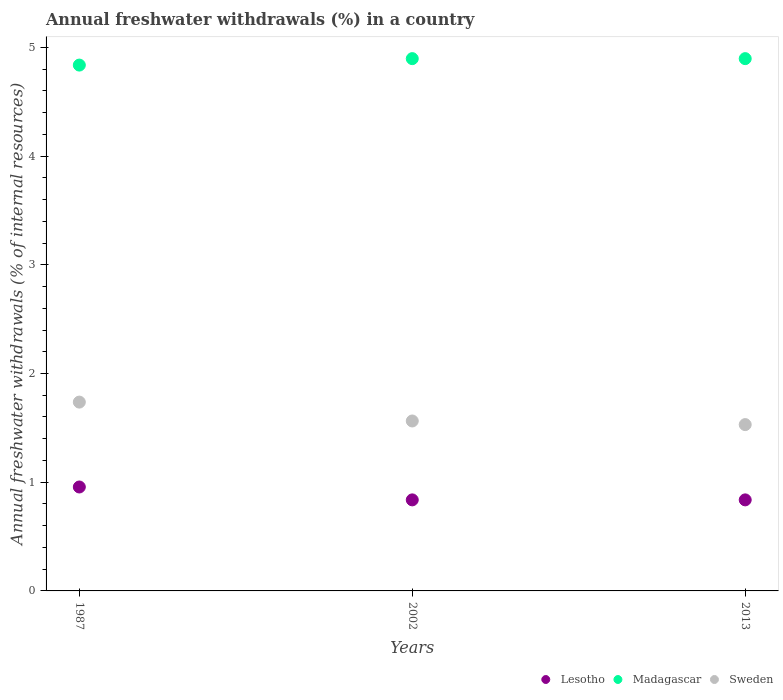How many different coloured dotlines are there?
Provide a short and direct response. 3. Is the number of dotlines equal to the number of legend labels?
Offer a very short reply. Yes. What is the percentage of annual freshwater withdrawals in Lesotho in 1987?
Provide a succinct answer. 0.96. Across all years, what is the maximum percentage of annual freshwater withdrawals in Lesotho?
Offer a terse response. 0.96. Across all years, what is the minimum percentage of annual freshwater withdrawals in Sweden?
Give a very brief answer. 1.53. What is the total percentage of annual freshwater withdrawals in Madagascar in the graph?
Offer a terse response. 14.63. What is the difference between the percentage of annual freshwater withdrawals in Sweden in 2002 and that in 2013?
Provide a short and direct response. 0.03. What is the difference between the percentage of annual freshwater withdrawals in Sweden in 2013 and the percentage of annual freshwater withdrawals in Lesotho in 1987?
Your response must be concise. 0.57. What is the average percentage of annual freshwater withdrawals in Madagascar per year?
Offer a very short reply. 4.88. In the year 2013, what is the difference between the percentage of annual freshwater withdrawals in Lesotho and percentage of annual freshwater withdrawals in Madagascar?
Your response must be concise. -4.06. What is the ratio of the percentage of annual freshwater withdrawals in Madagascar in 1987 to that in 2013?
Keep it short and to the point. 0.99. What is the difference between the highest and the lowest percentage of annual freshwater withdrawals in Madagascar?
Provide a succinct answer. 0.06. Is it the case that in every year, the sum of the percentage of annual freshwater withdrawals in Madagascar and percentage of annual freshwater withdrawals in Sweden  is greater than the percentage of annual freshwater withdrawals in Lesotho?
Make the answer very short. Yes. Is the percentage of annual freshwater withdrawals in Madagascar strictly less than the percentage of annual freshwater withdrawals in Lesotho over the years?
Your answer should be very brief. No. How many dotlines are there?
Your answer should be compact. 3. How many years are there in the graph?
Give a very brief answer. 3. Are the values on the major ticks of Y-axis written in scientific E-notation?
Offer a terse response. No. Does the graph contain grids?
Offer a very short reply. No. Where does the legend appear in the graph?
Your answer should be compact. Bottom right. How many legend labels are there?
Provide a succinct answer. 3. What is the title of the graph?
Offer a very short reply. Annual freshwater withdrawals (%) in a country. Does "Spain" appear as one of the legend labels in the graph?
Provide a short and direct response. No. What is the label or title of the Y-axis?
Provide a succinct answer. Annual freshwater withdrawals (% of internal resources). What is the Annual freshwater withdrawals (% of internal resources) in Lesotho in 1987?
Your answer should be very brief. 0.96. What is the Annual freshwater withdrawals (% of internal resources) in Madagascar in 1987?
Keep it short and to the point. 4.84. What is the Annual freshwater withdrawals (% of internal resources) in Sweden in 1987?
Provide a succinct answer. 1.74. What is the Annual freshwater withdrawals (% of internal resources) of Lesotho in 2002?
Offer a terse response. 0.84. What is the Annual freshwater withdrawals (% of internal resources) in Madagascar in 2002?
Provide a succinct answer. 4.9. What is the Annual freshwater withdrawals (% of internal resources) in Sweden in 2002?
Keep it short and to the point. 1.56. What is the Annual freshwater withdrawals (% of internal resources) in Lesotho in 2013?
Provide a succinct answer. 0.84. What is the Annual freshwater withdrawals (% of internal resources) in Madagascar in 2013?
Your answer should be very brief. 4.9. What is the Annual freshwater withdrawals (% of internal resources) in Sweden in 2013?
Give a very brief answer. 1.53. Across all years, what is the maximum Annual freshwater withdrawals (% of internal resources) of Lesotho?
Your answer should be very brief. 0.96. Across all years, what is the maximum Annual freshwater withdrawals (% of internal resources) of Madagascar?
Your answer should be compact. 4.9. Across all years, what is the maximum Annual freshwater withdrawals (% of internal resources) in Sweden?
Provide a short and direct response. 1.74. Across all years, what is the minimum Annual freshwater withdrawals (% of internal resources) of Lesotho?
Provide a short and direct response. 0.84. Across all years, what is the minimum Annual freshwater withdrawals (% of internal resources) of Madagascar?
Ensure brevity in your answer.  4.84. Across all years, what is the minimum Annual freshwater withdrawals (% of internal resources) of Sweden?
Your answer should be compact. 1.53. What is the total Annual freshwater withdrawals (% of internal resources) in Lesotho in the graph?
Your response must be concise. 2.63. What is the total Annual freshwater withdrawals (% of internal resources) of Madagascar in the graph?
Ensure brevity in your answer.  14.63. What is the total Annual freshwater withdrawals (% of internal resources) of Sweden in the graph?
Give a very brief answer. 4.83. What is the difference between the Annual freshwater withdrawals (% of internal resources) in Lesotho in 1987 and that in 2002?
Provide a short and direct response. 0.12. What is the difference between the Annual freshwater withdrawals (% of internal resources) in Madagascar in 1987 and that in 2002?
Your answer should be compact. -0.06. What is the difference between the Annual freshwater withdrawals (% of internal resources) of Sweden in 1987 and that in 2002?
Offer a very short reply. 0.17. What is the difference between the Annual freshwater withdrawals (% of internal resources) of Lesotho in 1987 and that in 2013?
Give a very brief answer. 0.12. What is the difference between the Annual freshwater withdrawals (% of internal resources) of Madagascar in 1987 and that in 2013?
Provide a short and direct response. -0.06. What is the difference between the Annual freshwater withdrawals (% of internal resources) in Sweden in 1987 and that in 2013?
Your response must be concise. 0.21. What is the difference between the Annual freshwater withdrawals (% of internal resources) in Lesotho in 2002 and that in 2013?
Offer a very short reply. 0. What is the difference between the Annual freshwater withdrawals (% of internal resources) in Sweden in 2002 and that in 2013?
Offer a very short reply. 0.03. What is the difference between the Annual freshwater withdrawals (% of internal resources) of Lesotho in 1987 and the Annual freshwater withdrawals (% of internal resources) of Madagascar in 2002?
Ensure brevity in your answer.  -3.94. What is the difference between the Annual freshwater withdrawals (% of internal resources) of Lesotho in 1987 and the Annual freshwater withdrawals (% of internal resources) of Sweden in 2002?
Provide a succinct answer. -0.61. What is the difference between the Annual freshwater withdrawals (% of internal resources) in Madagascar in 1987 and the Annual freshwater withdrawals (% of internal resources) in Sweden in 2002?
Your answer should be very brief. 3.27. What is the difference between the Annual freshwater withdrawals (% of internal resources) in Lesotho in 1987 and the Annual freshwater withdrawals (% of internal resources) in Madagascar in 2013?
Give a very brief answer. -3.94. What is the difference between the Annual freshwater withdrawals (% of internal resources) of Lesotho in 1987 and the Annual freshwater withdrawals (% of internal resources) of Sweden in 2013?
Keep it short and to the point. -0.57. What is the difference between the Annual freshwater withdrawals (% of internal resources) of Madagascar in 1987 and the Annual freshwater withdrawals (% of internal resources) of Sweden in 2013?
Your response must be concise. 3.31. What is the difference between the Annual freshwater withdrawals (% of internal resources) of Lesotho in 2002 and the Annual freshwater withdrawals (% of internal resources) of Madagascar in 2013?
Your response must be concise. -4.06. What is the difference between the Annual freshwater withdrawals (% of internal resources) in Lesotho in 2002 and the Annual freshwater withdrawals (% of internal resources) in Sweden in 2013?
Provide a short and direct response. -0.69. What is the difference between the Annual freshwater withdrawals (% of internal resources) of Madagascar in 2002 and the Annual freshwater withdrawals (% of internal resources) of Sweden in 2013?
Make the answer very short. 3.37. What is the average Annual freshwater withdrawals (% of internal resources) of Lesotho per year?
Offer a very short reply. 0.88. What is the average Annual freshwater withdrawals (% of internal resources) in Madagascar per year?
Provide a succinct answer. 4.88. What is the average Annual freshwater withdrawals (% of internal resources) of Sweden per year?
Give a very brief answer. 1.61. In the year 1987, what is the difference between the Annual freshwater withdrawals (% of internal resources) in Lesotho and Annual freshwater withdrawals (% of internal resources) in Madagascar?
Your answer should be very brief. -3.88. In the year 1987, what is the difference between the Annual freshwater withdrawals (% of internal resources) of Lesotho and Annual freshwater withdrawals (% of internal resources) of Sweden?
Your response must be concise. -0.78. In the year 2002, what is the difference between the Annual freshwater withdrawals (% of internal resources) of Lesotho and Annual freshwater withdrawals (% of internal resources) of Madagascar?
Offer a very short reply. -4.06. In the year 2002, what is the difference between the Annual freshwater withdrawals (% of internal resources) in Lesotho and Annual freshwater withdrawals (% of internal resources) in Sweden?
Provide a succinct answer. -0.73. In the year 2002, what is the difference between the Annual freshwater withdrawals (% of internal resources) of Madagascar and Annual freshwater withdrawals (% of internal resources) of Sweden?
Keep it short and to the point. 3.33. In the year 2013, what is the difference between the Annual freshwater withdrawals (% of internal resources) in Lesotho and Annual freshwater withdrawals (% of internal resources) in Madagascar?
Provide a succinct answer. -4.06. In the year 2013, what is the difference between the Annual freshwater withdrawals (% of internal resources) of Lesotho and Annual freshwater withdrawals (% of internal resources) of Sweden?
Keep it short and to the point. -0.69. In the year 2013, what is the difference between the Annual freshwater withdrawals (% of internal resources) in Madagascar and Annual freshwater withdrawals (% of internal resources) in Sweden?
Provide a succinct answer. 3.37. What is the ratio of the Annual freshwater withdrawals (% of internal resources) of Lesotho in 1987 to that in 2002?
Ensure brevity in your answer.  1.14. What is the ratio of the Annual freshwater withdrawals (% of internal resources) in Madagascar in 1987 to that in 2002?
Offer a very short reply. 0.99. What is the ratio of the Annual freshwater withdrawals (% of internal resources) of Lesotho in 1987 to that in 2013?
Provide a short and direct response. 1.14. What is the ratio of the Annual freshwater withdrawals (% of internal resources) of Madagascar in 1987 to that in 2013?
Your answer should be compact. 0.99. What is the ratio of the Annual freshwater withdrawals (% of internal resources) in Sweden in 1987 to that in 2013?
Provide a short and direct response. 1.14. What is the ratio of the Annual freshwater withdrawals (% of internal resources) of Sweden in 2002 to that in 2013?
Provide a short and direct response. 1.02. What is the difference between the highest and the second highest Annual freshwater withdrawals (% of internal resources) in Lesotho?
Provide a short and direct response. 0.12. What is the difference between the highest and the second highest Annual freshwater withdrawals (% of internal resources) in Sweden?
Offer a very short reply. 0.17. What is the difference between the highest and the lowest Annual freshwater withdrawals (% of internal resources) in Lesotho?
Give a very brief answer. 0.12. What is the difference between the highest and the lowest Annual freshwater withdrawals (% of internal resources) of Madagascar?
Your answer should be compact. 0.06. What is the difference between the highest and the lowest Annual freshwater withdrawals (% of internal resources) of Sweden?
Ensure brevity in your answer.  0.21. 